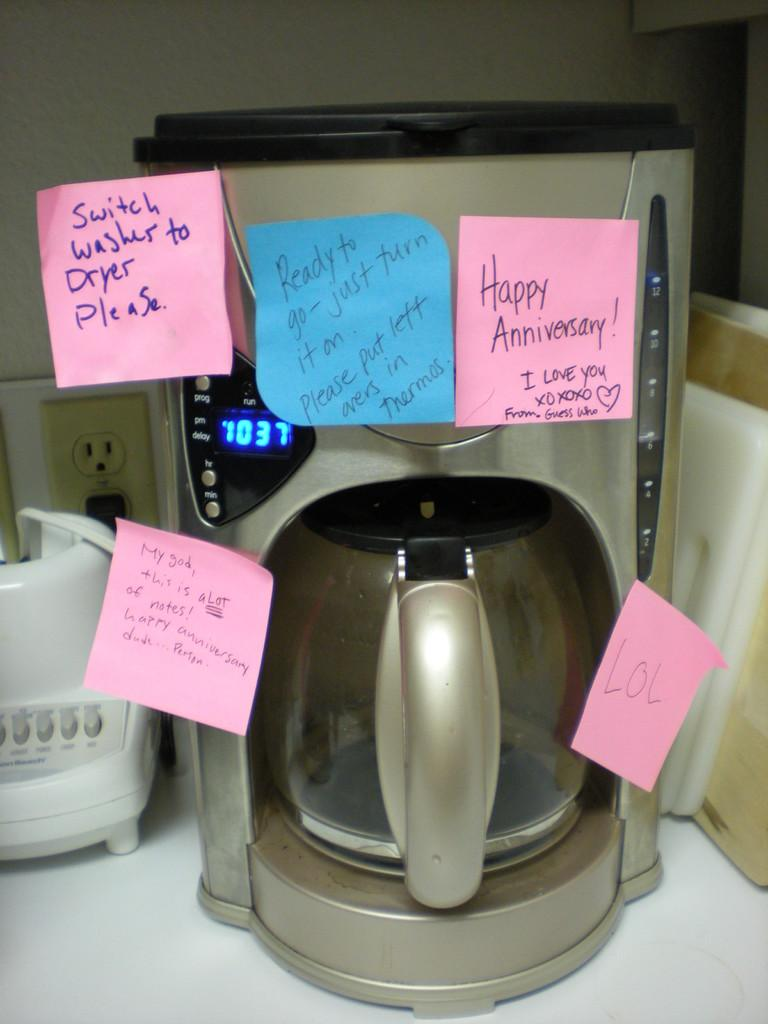<image>
Provide a brief description of the given image. Post it notes giving spouse instructions for the day, posted on a coffeemaker. 